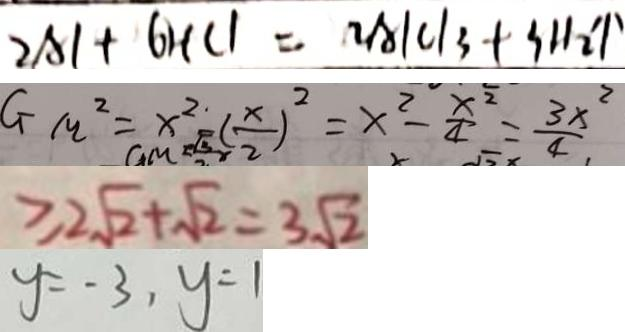Convert formula to latex. <formula><loc_0><loc_0><loc_500><loc_500>2 A l + 6 H C l = 2 A l C l _ { 3 } + 3 H _ { 2 } \uparrow 
 G _ { m } ^ { 2 } = x ^ { 2 } ( \frac { x } { 2 } ) ^ { 2 } = x ^ { 2 } - \frac { x ^ { 2 } } { 4 } = \frac { 3 x ^ { 2 } } { 4 } 
 \geq 2 \sqrt { 2 } + \sqrt { 2 } = 3 \sqrt { 2 } 
 y = - 3 , y = 1</formula> 